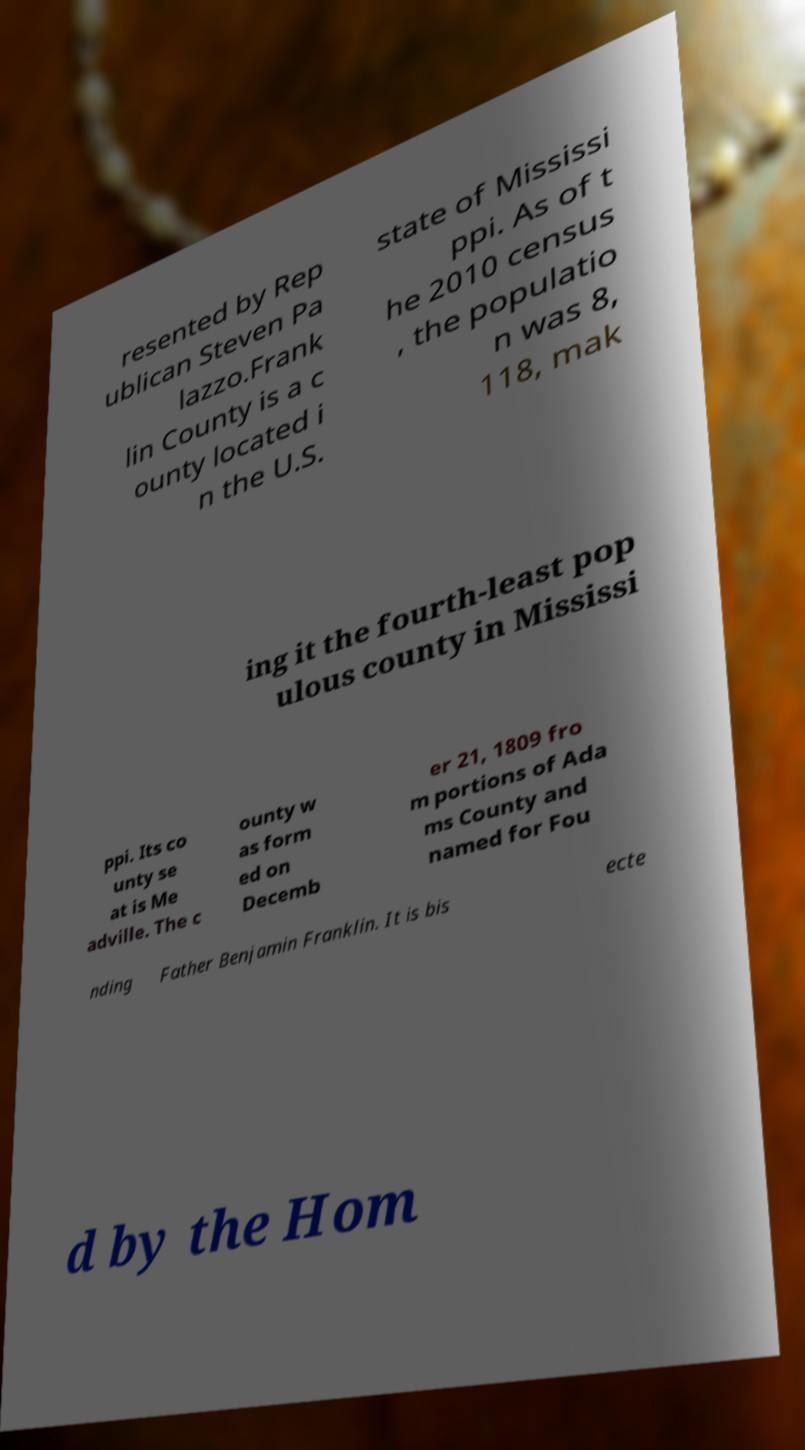Can you accurately transcribe the text from the provided image for me? resented by Rep ublican Steven Pa lazzo.Frank lin County is a c ounty located i n the U.S. state of Mississi ppi. As of t he 2010 census , the populatio n was 8, 118, mak ing it the fourth-least pop ulous county in Mississi ppi. Its co unty se at is Me adville. The c ounty w as form ed on Decemb er 21, 1809 fro m portions of Ada ms County and named for Fou nding Father Benjamin Franklin. It is bis ecte d by the Hom 